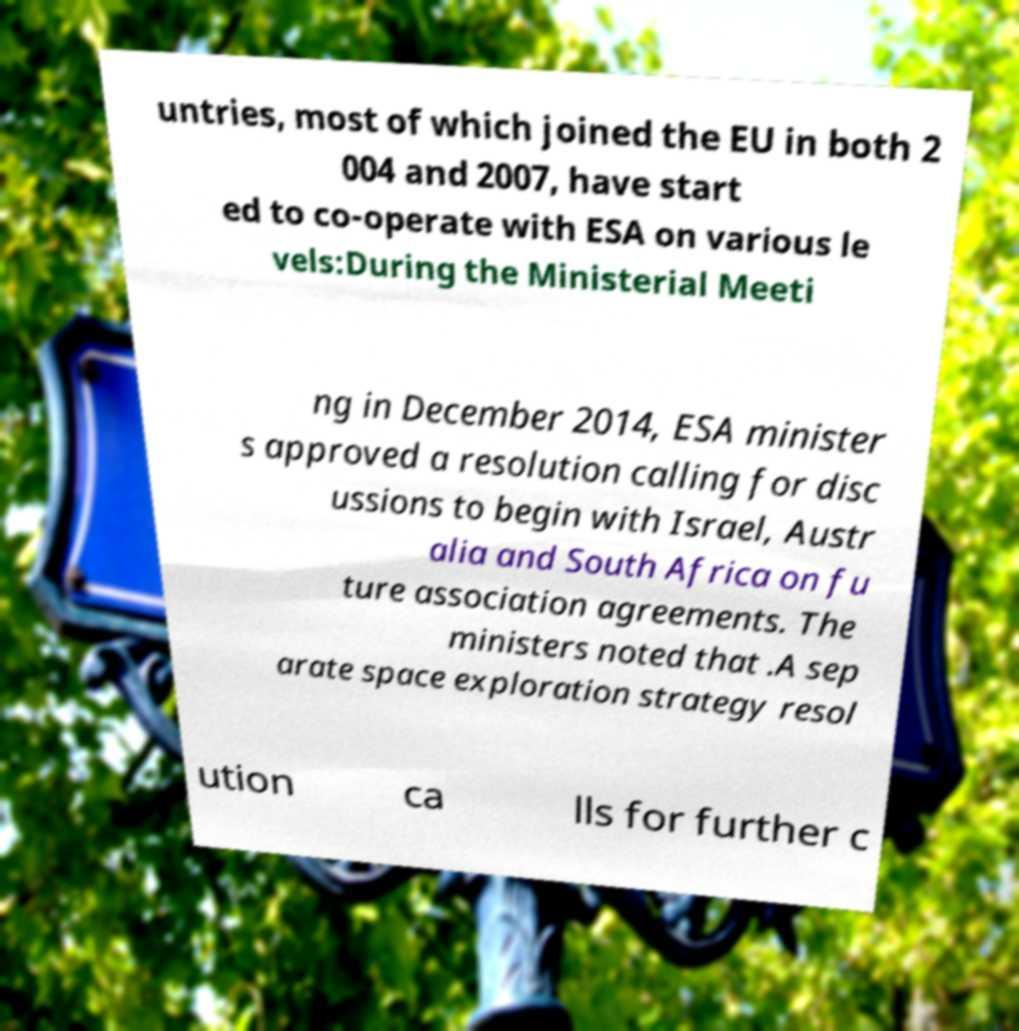What messages or text are displayed in this image? I need them in a readable, typed format. untries, most of which joined the EU in both 2 004 and 2007, have start ed to co-operate with ESA on various le vels:During the Ministerial Meeti ng in December 2014, ESA minister s approved a resolution calling for disc ussions to begin with Israel, Austr alia and South Africa on fu ture association agreements. The ministers noted that .A sep arate space exploration strategy resol ution ca lls for further c 